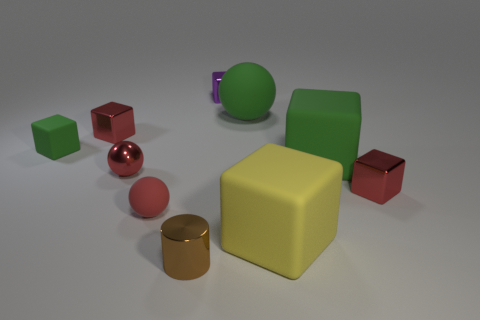What size is the sphere that is the same color as the small rubber cube?
Your answer should be very brief. Large. What number of tiny matte spheres are behind the sphere in front of the tiny metallic cube to the right of the big green matte block?
Offer a very short reply. 0. There is a big green object in front of the green matte ball; does it have the same shape as the green rubber thing that is left of the small brown metal cylinder?
Your answer should be compact. Yes. What number of objects are either purple things or big cubes?
Offer a terse response. 3. There is a yellow cube right of the green rubber block that is to the left of the big yellow cube; what is it made of?
Provide a succinct answer. Rubber. Is there a large matte block that has the same color as the big ball?
Provide a short and direct response. Yes. The shiny ball that is the same size as the purple object is what color?
Offer a very short reply. Red. What is the material of the tiny red block on the right side of the object that is behind the rubber sphere right of the brown thing?
Provide a short and direct response. Metal. Is the color of the metal sphere the same as the metallic cube that is to the right of the large green ball?
Offer a very short reply. Yes. What number of objects are either green blocks on the left side of the small brown metal cylinder or tiny red objects to the left of the big yellow rubber thing?
Offer a very short reply. 4. 